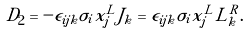Convert formula to latex. <formula><loc_0><loc_0><loc_500><loc_500>D _ { 2 } = - \epsilon _ { i j k } \sigma _ { i } x _ { j } ^ { L } J _ { k } = \epsilon _ { i j k } \sigma _ { i } x _ { j } ^ { L } L _ { k } ^ { R } .</formula> 